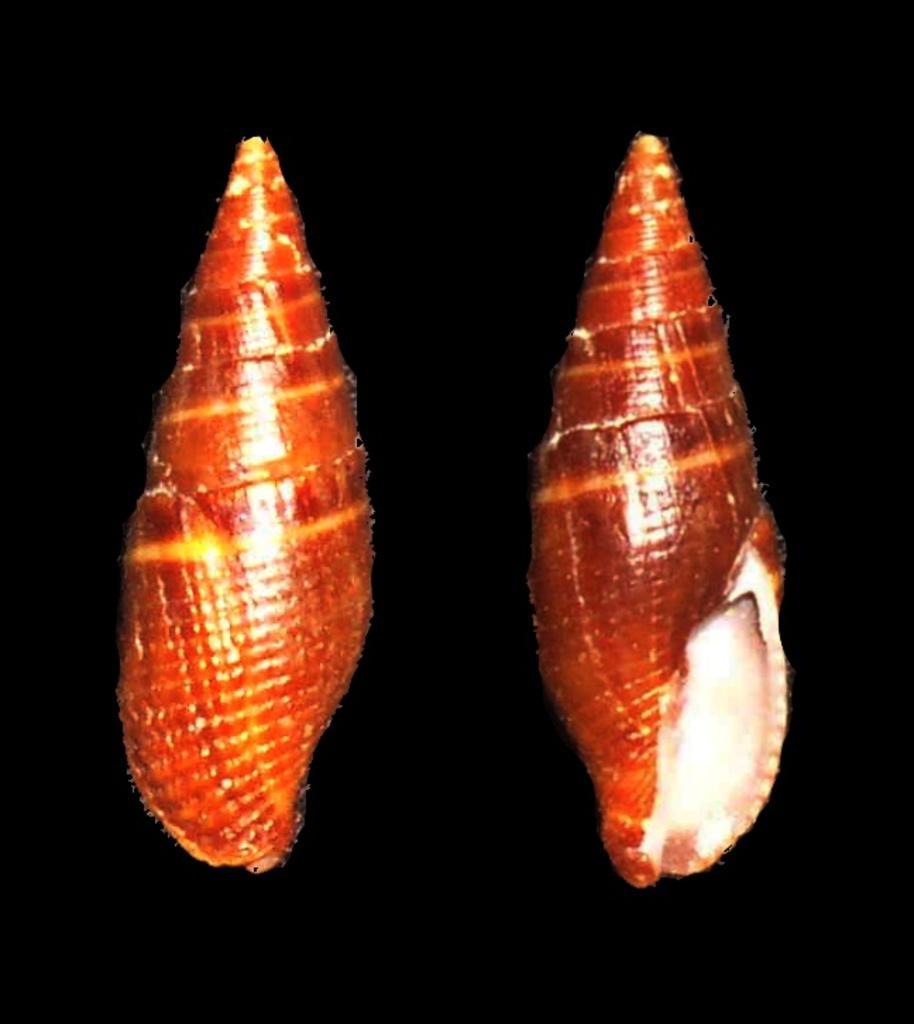In one or two sentences, can you explain what this image depicts? As we can see in the image there are orange color shells. 